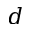Convert formula to latex. <formula><loc_0><loc_0><loc_500><loc_500>d</formula> 